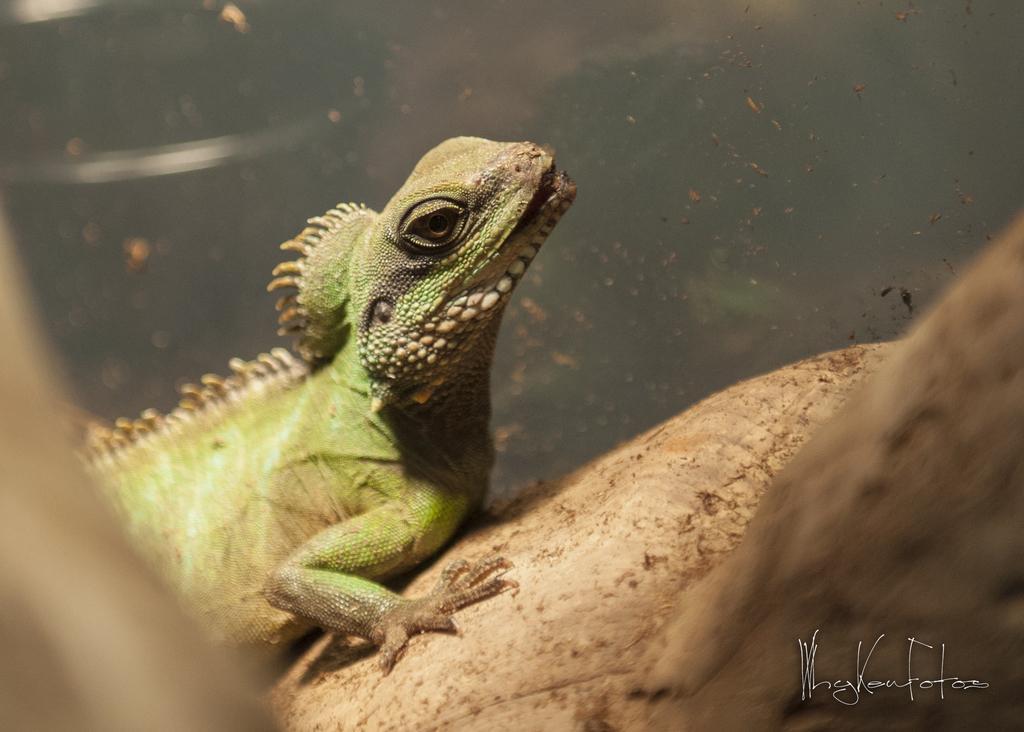Please provide a concise description of this image. In this image, we can see a garden lizard on the wood and at the bottom, there is some text. 